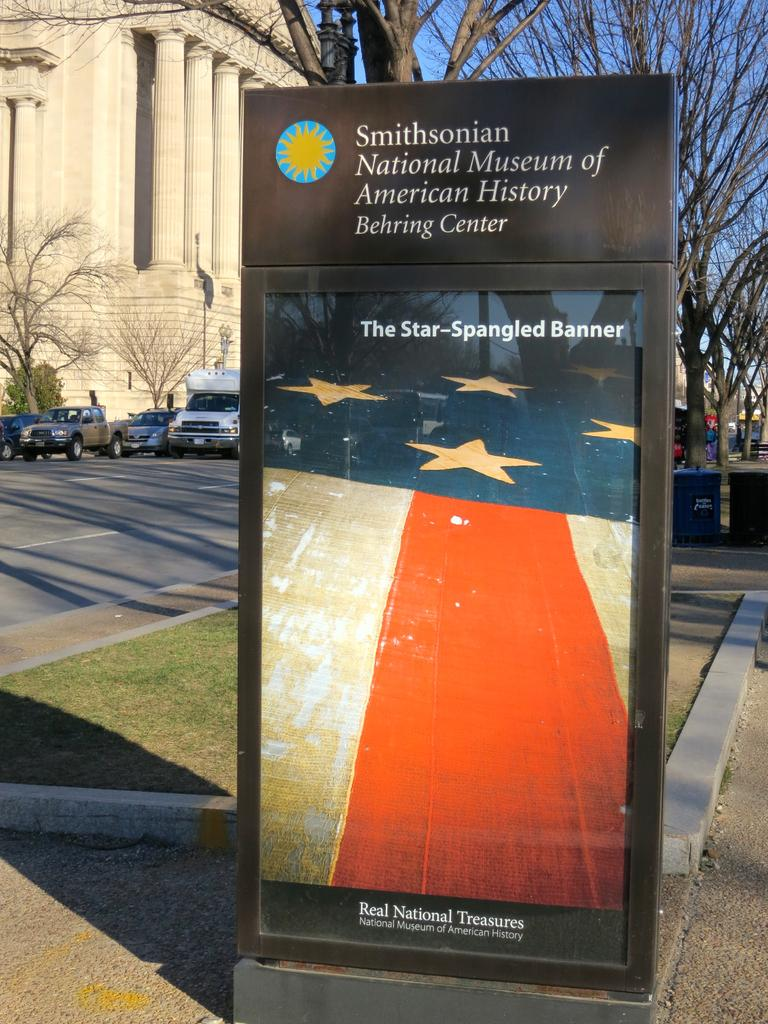<image>
Describe the image concisely. A large poster sits in a black box on the street highlighting real national treasures. 